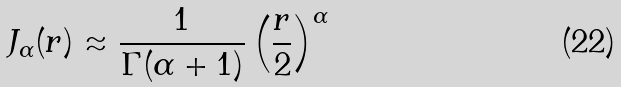<formula> <loc_0><loc_0><loc_500><loc_500>J _ { \alpha } ( r ) \approx \frac { 1 } { \Gamma ( \alpha + 1 ) } \left ( \frac { r } { 2 } \right ) ^ { \alpha }</formula> 